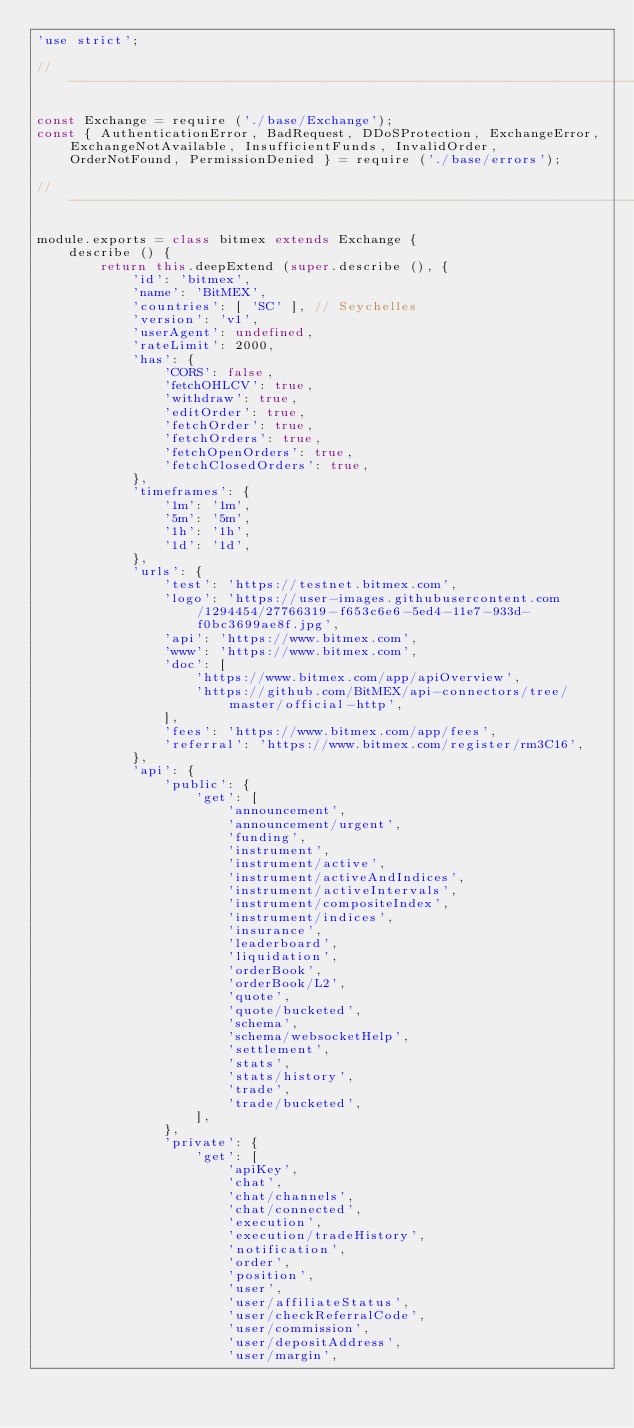<code> <loc_0><loc_0><loc_500><loc_500><_JavaScript_>'use strict';

//  ---------------------------------------------------------------------------

const Exchange = require ('./base/Exchange');
const { AuthenticationError, BadRequest, DDoSProtection, ExchangeError, ExchangeNotAvailable, InsufficientFunds, InvalidOrder, OrderNotFound, PermissionDenied } = require ('./base/errors');

//  ---------------------------------------------------------------------------

module.exports = class bitmex extends Exchange {
    describe () {
        return this.deepExtend (super.describe (), {
            'id': 'bitmex',
            'name': 'BitMEX',
            'countries': [ 'SC' ], // Seychelles
            'version': 'v1',
            'userAgent': undefined,
            'rateLimit': 2000,
            'has': {
                'CORS': false,
                'fetchOHLCV': true,
                'withdraw': true,
                'editOrder': true,
                'fetchOrder': true,
                'fetchOrders': true,
                'fetchOpenOrders': true,
                'fetchClosedOrders': true,
            },
            'timeframes': {
                '1m': '1m',
                '5m': '5m',
                '1h': '1h',
                '1d': '1d',
            },
            'urls': {
                'test': 'https://testnet.bitmex.com',
                'logo': 'https://user-images.githubusercontent.com/1294454/27766319-f653c6e6-5ed4-11e7-933d-f0bc3699ae8f.jpg',
                'api': 'https://www.bitmex.com',
                'www': 'https://www.bitmex.com',
                'doc': [
                    'https://www.bitmex.com/app/apiOverview',
                    'https://github.com/BitMEX/api-connectors/tree/master/official-http',
                ],
                'fees': 'https://www.bitmex.com/app/fees',
                'referral': 'https://www.bitmex.com/register/rm3C16',
            },
            'api': {
                'public': {
                    'get': [
                        'announcement',
                        'announcement/urgent',
                        'funding',
                        'instrument',
                        'instrument/active',
                        'instrument/activeAndIndices',
                        'instrument/activeIntervals',
                        'instrument/compositeIndex',
                        'instrument/indices',
                        'insurance',
                        'leaderboard',
                        'liquidation',
                        'orderBook',
                        'orderBook/L2',
                        'quote',
                        'quote/bucketed',
                        'schema',
                        'schema/websocketHelp',
                        'settlement',
                        'stats',
                        'stats/history',
                        'trade',
                        'trade/bucketed',
                    ],
                },
                'private': {
                    'get': [
                        'apiKey',
                        'chat',
                        'chat/channels',
                        'chat/connected',
                        'execution',
                        'execution/tradeHistory',
                        'notification',
                        'order',
                        'position',
                        'user',
                        'user/affiliateStatus',
                        'user/checkReferralCode',
                        'user/commission',
                        'user/depositAddress',
                        'user/margin',</code> 